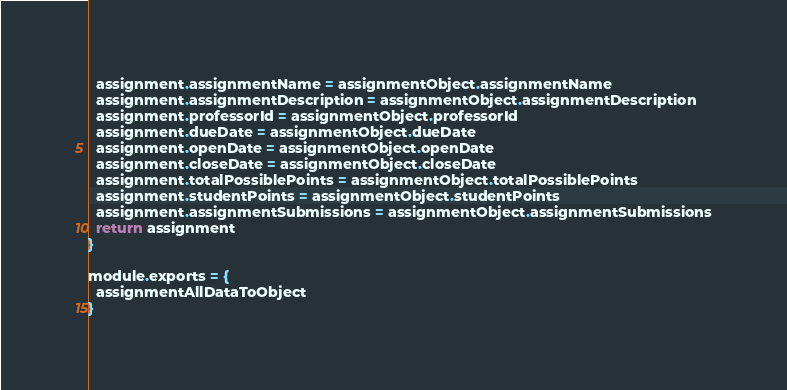Convert code to text. <code><loc_0><loc_0><loc_500><loc_500><_JavaScript_>  assignment.assignmentName = assignmentObject.assignmentName
  assignment.assignmentDescription = assignmentObject.assignmentDescription
  assignment.professorId = assignmentObject.professorId
  assignment.dueDate = assignmentObject.dueDate
  assignment.openDate = assignmentObject.openDate
  assignment.closeDate = assignmentObject.closeDate
  assignment.totalPossiblePoints = assignmentObject.totalPossiblePoints
  assignment.studentPoints = assignmentObject.studentPoints
  assignment.assignmentSubmissions = assignmentObject.assignmentSubmissions
  return assignment
}

module.exports = {
  assignmentAllDataToObject
}</code> 